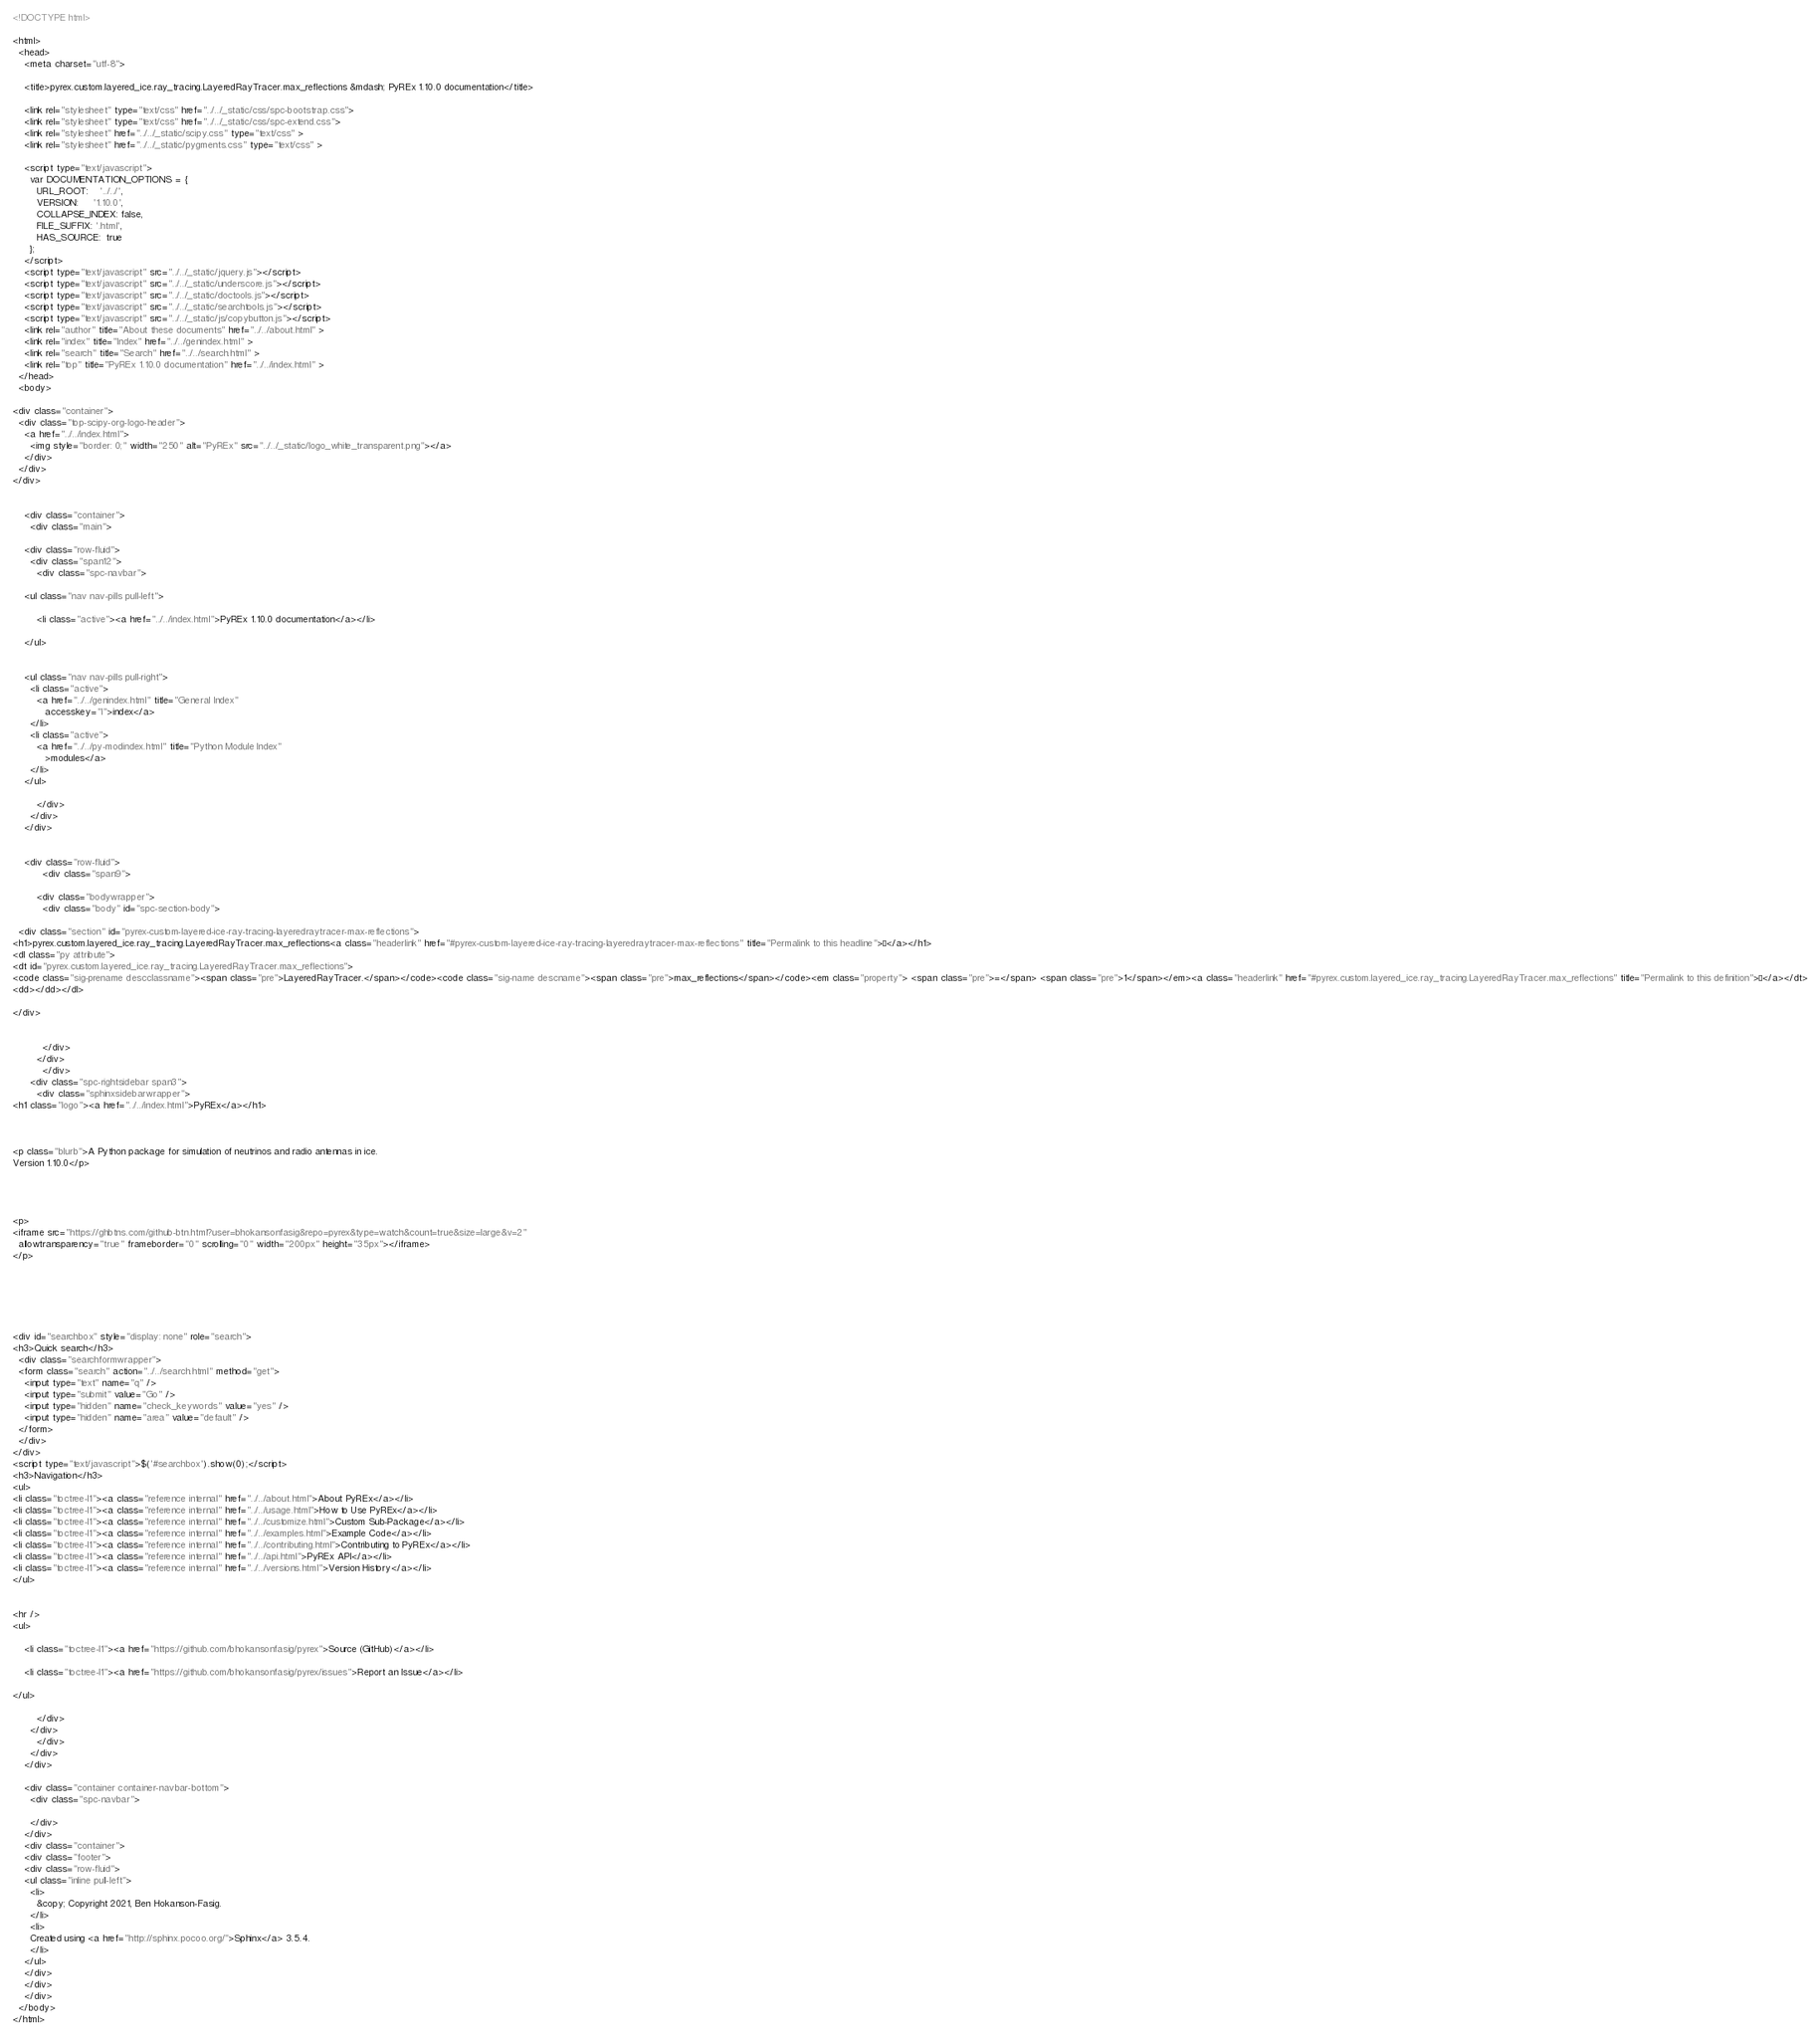<code> <loc_0><loc_0><loc_500><loc_500><_HTML_><!DOCTYPE html>

<html>
  <head>
    <meta charset="utf-8">
    
    <title>pyrex.custom.layered_ice.ray_tracing.LayeredRayTracer.max_reflections &mdash; PyREx 1.10.0 documentation</title>
    
    <link rel="stylesheet" type="text/css" href="../../_static/css/spc-bootstrap.css">
    <link rel="stylesheet" type="text/css" href="../../_static/css/spc-extend.css">
    <link rel="stylesheet" href="../../_static/scipy.css" type="text/css" >
    <link rel="stylesheet" href="../../_static/pygments.css" type="text/css" >
    
    <script type="text/javascript">
      var DOCUMENTATION_OPTIONS = {
        URL_ROOT:    '../../',
        VERSION:     '1.10.0',
        COLLAPSE_INDEX: false,
        FILE_SUFFIX: '.html',
        HAS_SOURCE:  true
      };
    </script>
    <script type="text/javascript" src="../../_static/jquery.js"></script>
    <script type="text/javascript" src="../../_static/underscore.js"></script>
    <script type="text/javascript" src="../../_static/doctools.js"></script>
    <script type="text/javascript" src="../../_static/searchtools.js"></script>
    <script type="text/javascript" src="../../_static/js/copybutton.js"></script>
    <link rel="author" title="About these documents" href="../../about.html" >
    <link rel="index" title="Index" href="../../genindex.html" >
    <link rel="search" title="Search" href="../../search.html" >
    <link rel="top" title="PyREx 1.10.0 documentation" href="../../index.html" > 
  </head>
  <body>

<div class="container">
  <div class="top-scipy-org-logo-header">
    <a href="../../index.html">
      <img style="border: 0;" width="250" alt="PyREx" src="../../_static/logo_white_transparent.png"></a>
    </div>
  </div>
</div>


    <div class="container">
      <div class="main">
        
	<div class="row-fluid">
	  <div class="span12">
	    <div class="spc-navbar">
              
    <ul class="nav nav-pills pull-left">
	
        <li class="active"><a href="../../index.html">PyREx 1.10.0 documentation</a></li>
	 
    </ul>
              
              
    <ul class="nav nav-pills pull-right">
      <li class="active">
        <a href="../../genindex.html" title="General Index"
           accesskey="I">index</a>
      </li>
      <li class="active">
        <a href="../../py-modindex.html" title="Python Module Index"
           >modules</a>
      </li>
    </ul>
              
	    </div>
	  </div>
	</div>
        

	<div class="row-fluid">
          <div class="span9">
            
        <div class="bodywrapper">
          <div class="body" id="spc-section-body">
            
  <div class="section" id="pyrex-custom-layered-ice-ray-tracing-layeredraytracer-max-reflections">
<h1>pyrex.custom.layered_ice.ray_tracing.LayeredRayTracer.max_reflections<a class="headerlink" href="#pyrex-custom-layered-ice-ray-tracing-layeredraytracer-max-reflections" title="Permalink to this headline">¶</a></h1>
<dl class="py attribute">
<dt id="pyrex.custom.layered_ice.ray_tracing.LayeredRayTracer.max_reflections">
<code class="sig-prename descclassname"><span class="pre">LayeredRayTracer.</span></code><code class="sig-name descname"><span class="pre">max_reflections</span></code><em class="property"> <span class="pre">=</span> <span class="pre">1</span></em><a class="headerlink" href="#pyrex.custom.layered_ice.ray_tracing.LayeredRayTracer.max_reflections" title="Permalink to this definition">¶</a></dt>
<dd></dd></dl>

</div>


          </div>
        </div>
          </div>
      <div class="spc-rightsidebar span3">
        <div class="sphinxsidebarwrapper">
<h1 class="logo"><a href="../../index.html">PyREx</a></h1>



<p class="blurb">A Python package for simulation of neutrinos and radio antennas in ice.
Version 1.10.0</p>




<p>
<iframe src="https://ghbtns.com/github-btn.html?user=bhokansonfasig&repo=pyrex&type=watch&count=true&size=large&v=2"
  allowtransparency="true" frameborder="0" scrolling="0" width="200px" height="35px"></iframe>
</p>






<div id="searchbox" style="display: none" role="search">
<h3>Quick search</h3>
  <div class="searchformwrapper">
  <form class="search" action="../../search.html" method="get">
    <input type="text" name="q" />
    <input type="submit" value="Go" />
    <input type="hidden" name="check_keywords" value="yes" />
    <input type="hidden" name="area" value="default" />
  </form>
  </div>
</div>
<script type="text/javascript">$('#searchbox').show(0);</script>
<h3>Navigation</h3>
<ul>
<li class="toctree-l1"><a class="reference internal" href="../../about.html">About PyREx</a></li>
<li class="toctree-l1"><a class="reference internal" href="../../usage.html">How to Use PyREx</a></li>
<li class="toctree-l1"><a class="reference internal" href="../../customize.html">Custom Sub-Package</a></li>
<li class="toctree-l1"><a class="reference internal" href="../../examples.html">Example Code</a></li>
<li class="toctree-l1"><a class="reference internal" href="../../contributing.html">Contributing to PyREx</a></li>
<li class="toctree-l1"><a class="reference internal" href="../../api.html">PyREx API</a></li>
<li class="toctree-l1"><a class="reference internal" href="../../versions.html">Version History</a></li>
</ul>


<hr />
<ul>
    
    <li class="toctree-l1"><a href="https://github.com/bhokansonfasig/pyrex">Source (GitHub)</a></li>
    
    <li class="toctree-l1"><a href="https://github.com/bhokansonfasig/pyrex/issues">Report an Issue</a></li>
    
</ul>

        </div>
      </div>
        </div>
      </div>
    </div>

    <div class="container container-navbar-bottom">
      <div class="spc-navbar">
        
      </div>
    </div>
    <div class="container">
    <div class="footer">
    <div class="row-fluid">
    <ul class="inline pull-left">
      <li>
        &copy; Copyright 2021, Ben Hokanson-Fasig.
      </li>
      <li>
      Created using <a href="http://sphinx.pocoo.org/">Sphinx</a> 3.5.4.
      </li>
    </ul>
    </div>
    </div>
    </div>
  </body>
</html></code> 